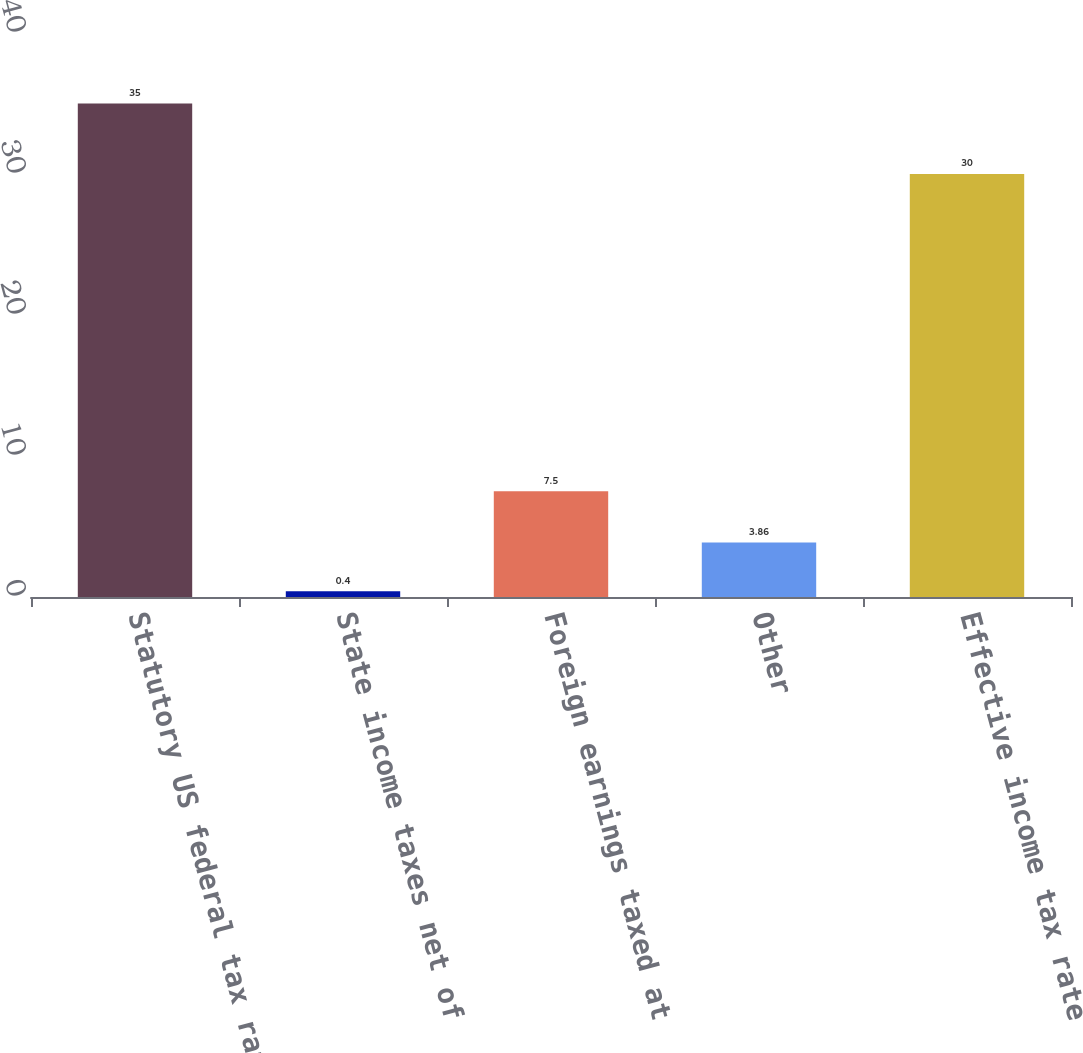<chart> <loc_0><loc_0><loc_500><loc_500><bar_chart><fcel>Statutory US federal tax rate<fcel>State income taxes net of<fcel>Foreign earnings taxed at<fcel>Other<fcel>Effective income tax rate<nl><fcel>35<fcel>0.4<fcel>7.5<fcel>3.86<fcel>30<nl></chart> 